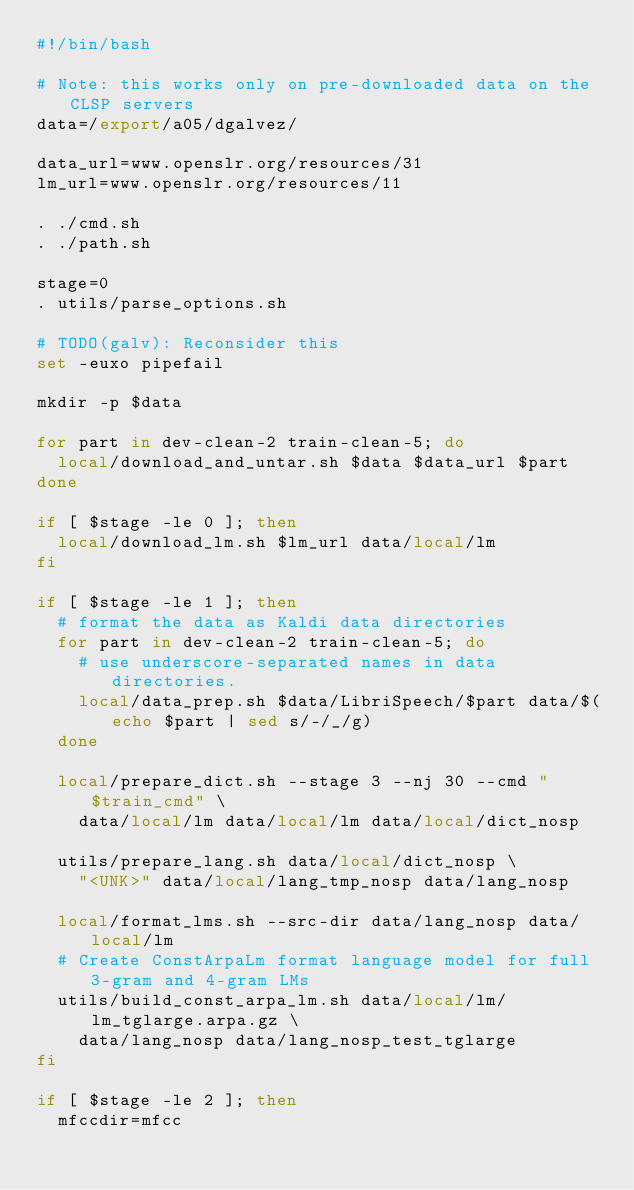<code> <loc_0><loc_0><loc_500><loc_500><_Bash_>#!/bin/bash

# Note: this works only on pre-downloaded data on the CLSP servers
data=/export/a05/dgalvez/

data_url=www.openslr.org/resources/31
lm_url=www.openslr.org/resources/11

. ./cmd.sh
. ./path.sh

stage=0
. utils/parse_options.sh

# TODO(galv): Reconsider this
set -euxo pipefail

mkdir -p $data

for part in dev-clean-2 train-clean-5; do
  local/download_and_untar.sh $data $data_url $part
done

if [ $stage -le 0 ]; then
  local/download_lm.sh $lm_url data/local/lm
fi

if [ $stage -le 1 ]; then
  # format the data as Kaldi data directories
  for part in dev-clean-2 train-clean-5; do
    # use underscore-separated names in data directories.
    local/data_prep.sh $data/LibriSpeech/$part data/$(echo $part | sed s/-/_/g)
  done

  local/prepare_dict.sh --stage 3 --nj 30 --cmd "$train_cmd" \
    data/local/lm data/local/lm data/local/dict_nosp

  utils/prepare_lang.sh data/local/dict_nosp \
    "<UNK>" data/local/lang_tmp_nosp data/lang_nosp

  local/format_lms.sh --src-dir data/lang_nosp data/local/lm
  # Create ConstArpaLm format language model for full 3-gram and 4-gram LMs
  utils/build_const_arpa_lm.sh data/local/lm/lm_tglarge.arpa.gz \
    data/lang_nosp data/lang_nosp_test_tglarge
fi

if [ $stage -le 2 ]; then
  mfccdir=mfcc</code> 